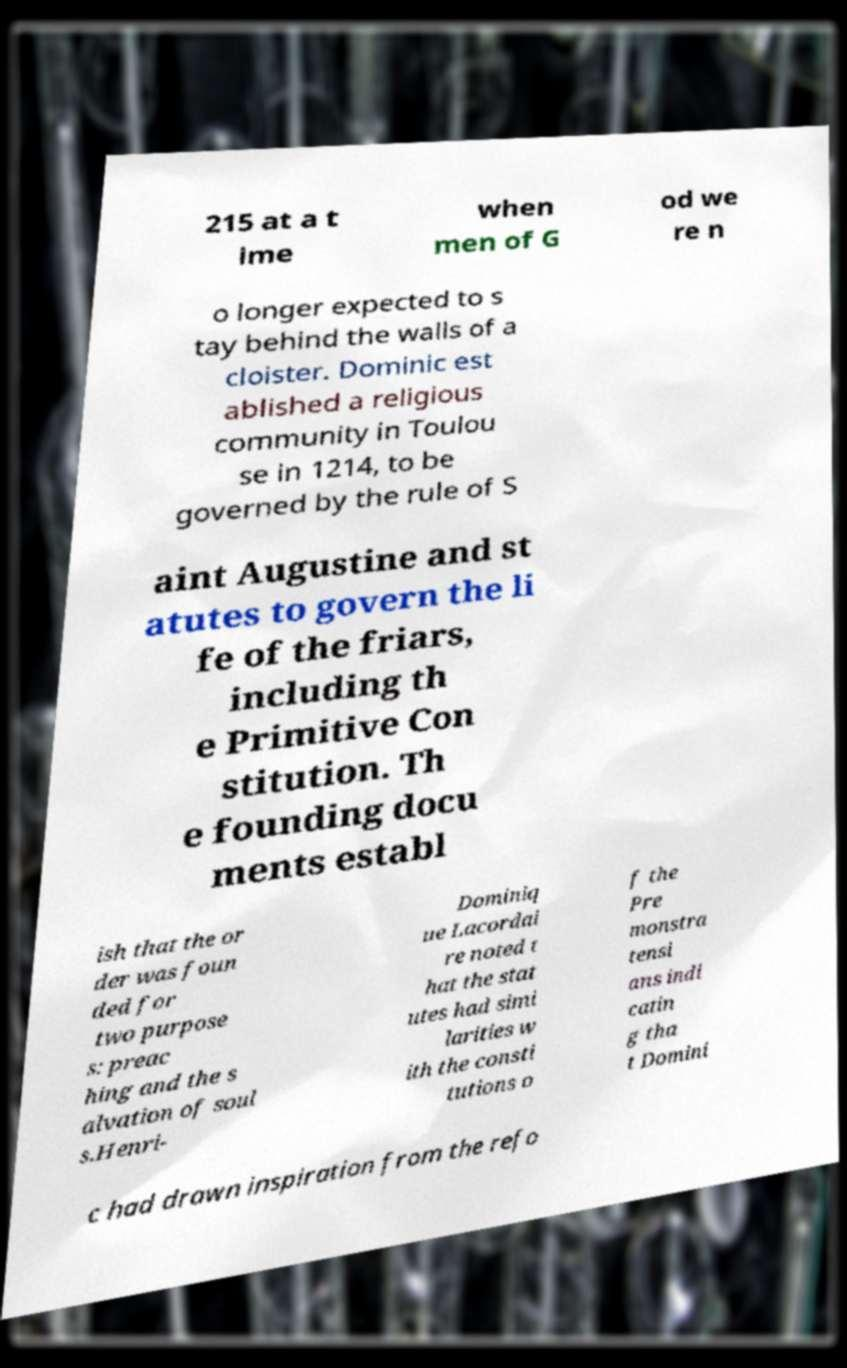There's text embedded in this image that I need extracted. Can you transcribe it verbatim? 215 at a t ime when men of G od we re n o longer expected to s tay behind the walls of a cloister. Dominic est ablished a religious community in Toulou se in 1214, to be governed by the rule of S aint Augustine and st atutes to govern the li fe of the friars, including th e Primitive Con stitution. Th e founding docu ments establ ish that the or der was foun ded for two purpose s: preac hing and the s alvation of soul s.Henri- Dominiq ue Lacordai re noted t hat the stat utes had simi larities w ith the consti tutions o f the Pre monstra tensi ans indi catin g tha t Domini c had drawn inspiration from the refo 